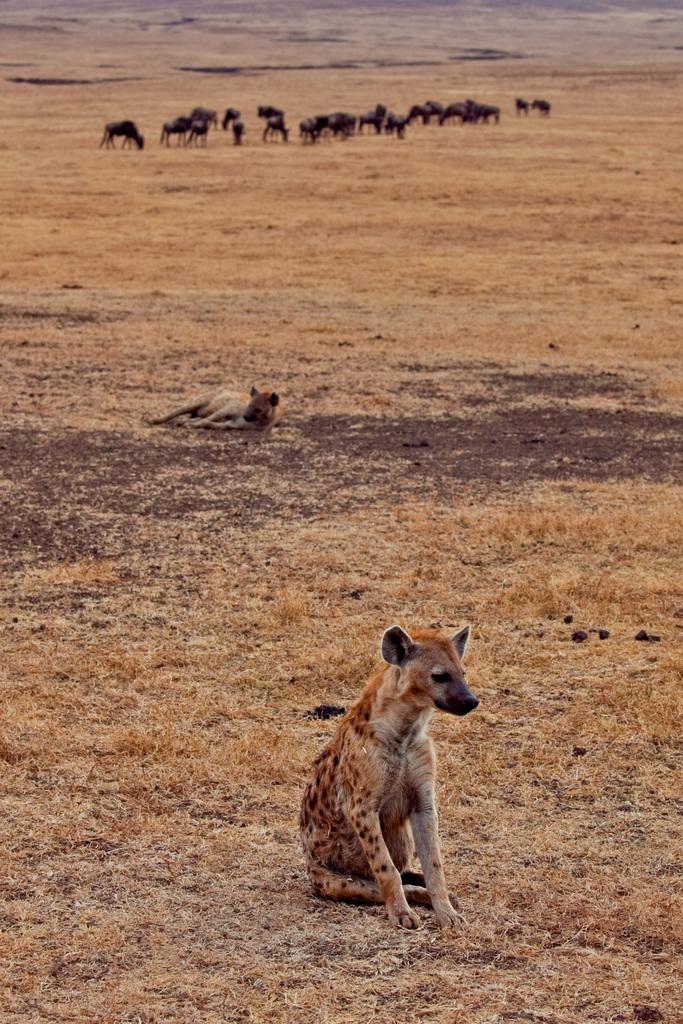In one or two sentences, can you explain what this image depicts? In this picture I can observe a hyena sitting on the ground in the bottom of the picture. In the background I can observe some animals on the ground. I can observe an open land in this picture. 